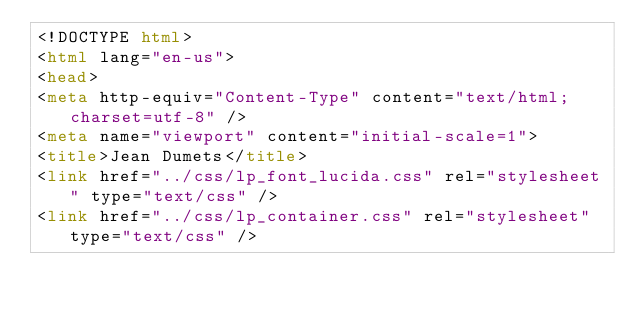<code> <loc_0><loc_0><loc_500><loc_500><_HTML_><!DOCTYPE html>
<html lang="en-us">
<head>
<meta http-equiv="Content-Type" content="text/html; charset=utf-8" />
<meta name="viewport" content="initial-scale=1">
<title>Jean Dumets</title>
<link href="../css/lp_font_lucida.css" rel="stylesheet" type="text/css" />
<link href="../css/lp_container.css" rel="stylesheet" type="text/css" /></code> 